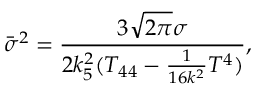Convert formula to latex. <formula><loc_0><loc_0><loc_500><loc_500>{ \bar { \sigma } } ^ { 2 } = \frac { 3 \sqrt { 2 \pi } \sigma } { 2 k _ { 5 } ^ { 2 } ( T _ { 4 4 } - \frac { 1 } { 1 6 k ^ { 2 } } T ^ { 4 } ) } ,</formula> 